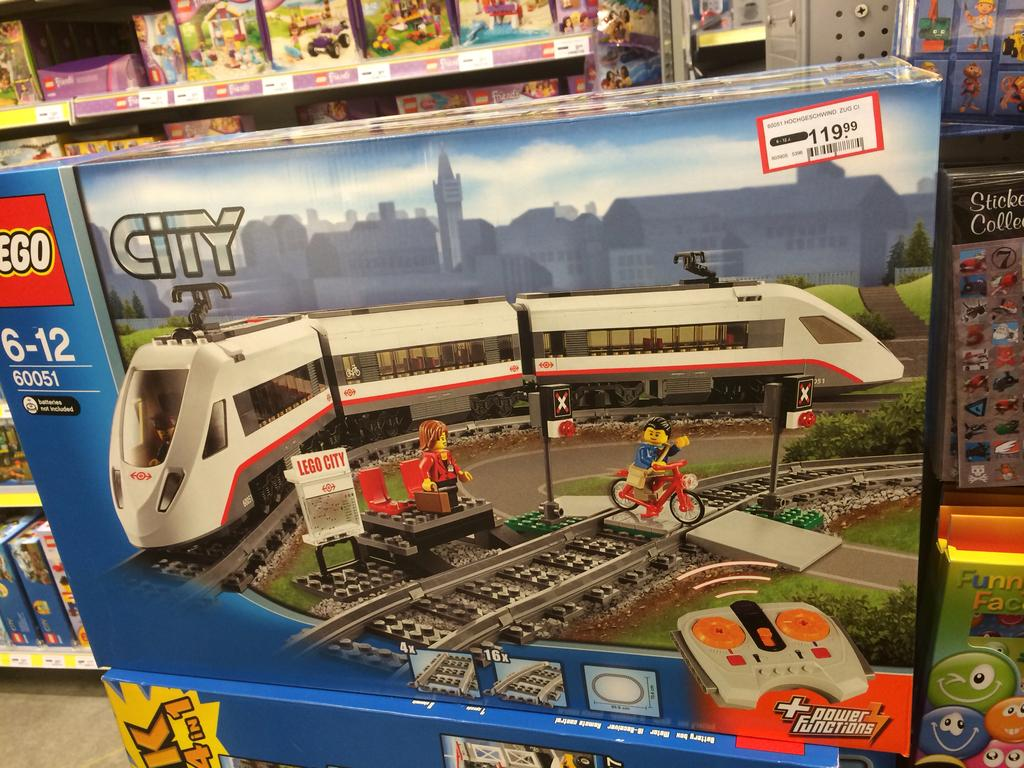What objects are present in the image? There are boxes in the image. What is inside the boxes? The boxes contain pictures of toys. Are there any labels or text on the boxes? Yes, there is text on the boxes. Can you describe the arrangement of the boxes in the image? There is a group of boxes placed on shelves in the background. How many clocks are hanging on the wall behind the boxes? There are no clocks visible in the image; the focus is on the boxes and their contents. 